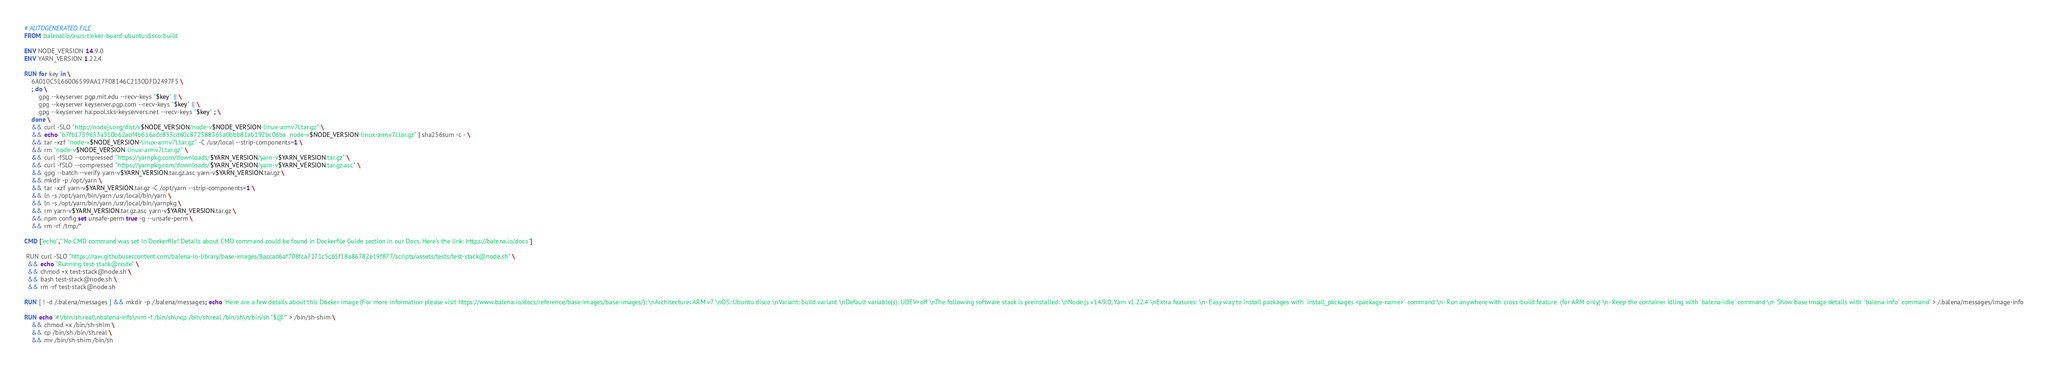<code> <loc_0><loc_0><loc_500><loc_500><_Dockerfile_># AUTOGENERATED FILE
FROM balenalib/asus-tinker-board-ubuntu:disco-build

ENV NODE_VERSION 14.9.0
ENV YARN_VERSION 1.22.4

RUN for key in \
	6A010C5166006599AA17F08146C2130DFD2497F5 \
	; do \
		gpg --keyserver pgp.mit.edu --recv-keys "$key" || \
		gpg --keyserver keyserver.pgp.com --recv-keys "$key" || \
		gpg --keyserver ha.pool.sks-keyservers.net --recv-keys "$key" ; \
	done \
	&& curl -SLO "http://nodejs.org/dist/v$NODE_VERSION/node-v$NODE_VERSION-linux-armv7l.tar.gz" \
	&& echo "b7fb1759653a510b62adf4b616adc853cd60c872588365a0bbb81ab192bc06ba  node-v$NODE_VERSION-linux-armv7l.tar.gz" | sha256sum -c - \
	&& tar -xzf "node-v$NODE_VERSION-linux-armv7l.tar.gz" -C /usr/local --strip-components=1 \
	&& rm "node-v$NODE_VERSION-linux-armv7l.tar.gz" \
	&& curl -fSLO --compressed "https://yarnpkg.com/downloads/$YARN_VERSION/yarn-v$YARN_VERSION.tar.gz" \
	&& curl -fSLO --compressed "https://yarnpkg.com/downloads/$YARN_VERSION/yarn-v$YARN_VERSION.tar.gz.asc" \
	&& gpg --batch --verify yarn-v$YARN_VERSION.tar.gz.asc yarn-v$YARN_VERSION.tar.gz \
	&& mkdir -p /opt/yarn \
	&& tar -xzf yarn-v$YARN_VERSION.tar.gz -C /opt/yarn --strip-components=1 \
	&& ln -s /opt/yarn/bin/yarn /usr/local/bin/yarn \
	&& ln -s /opt/yarn/bin/yarn /usr/local/bin/yarnpkg \
	&& rm yarn-v$YARN_VERSION.tar.gz.asc yarn-v$YARN_VERSION.tar.gz \
	&& npm config set unsafe-perm true -g --unsafe-perm \
	&& rm -rf /tmp/*

CMD ["echo","'No CMD command was set in Dockerfile! Details about CMD command could be found in Dockerfile Guide section in our Docs. Here's the link: https://balena.io/docs"]

 RUN curl -SLO "https://raw.githubusercontent.com/balena-io-library/base-images/8accad6af708fca7271c5c65f18a86782e19f877/scripts/assets/tests/test-stack@node.sh" \
  && echo "Running test-stack@node" \
  && chmod +x test-stack@node.sh \
  && bash test-stack@node.sh \
  && rm -rf test-stack@node.sh 

RUN [ ! -d /.balena/messages ] && mkdir -p /.balena/messages; echo 'Here are a few details about this Docker image (For more information please visit https://www.balena.io/docs/reference/base-images/base-images/): \nArchitecture: ARM v7 \nOS: Ubuntu disco \nVariant: build variant \nDefault variable(s): UDEV=off \nThe following software stack is preinstalled: \nNode.js v14.9.0, Yarn v1.22.4 \nExtra features: \n- Easy way to install packages with `install_packages <package-name>` command \n- Run anywhere with cross-build feature  (for ARM only) \n- Keep the container idling with `balena-idle` command \n- Show base image details with `balena-info` command' > /.balena/messages/image-info

RUN echo '#!/bin/sh.real\nbalena-info\nrm -f /bin/sh\ncp /bin/sh.real /bin/sh\n/bin/sh "$@"' > /bin/sh-shim \
	&& chmod +x /bin/sh-shim \
	&& cp /bin/sh /bin/sh.real \
	&& mv /bin/sh-shim /bin/sh</code> 